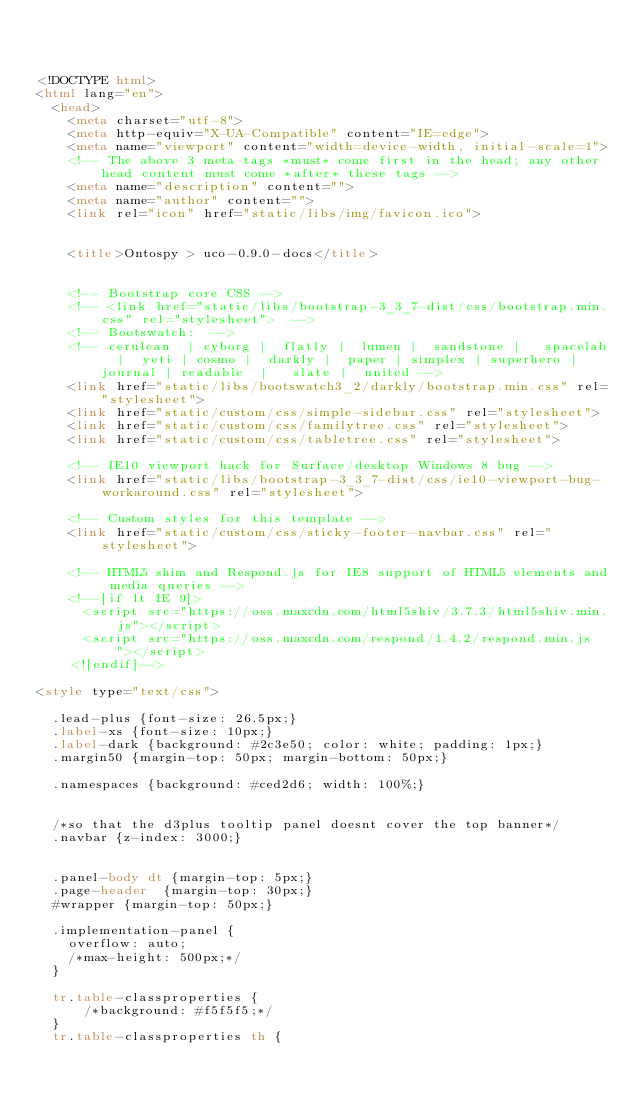<code> <loc_0><loc_0><loc_500><loc_500><_HTML_>


<!DOCTYPE html>
<html lang="en">
  <head>
    <meta charset="utf-8">
    <meta http-equiv="X-UA-Compatible" content="IE=edge">
    <meta name="viewport" content="width=device-width, initial-scale=1">
    <!-- The above 3 meta tags *must* come first in the head; any other head content must come *after* these tags -->
    <meta name="description" content="">
    <meta name="author" content="">
    <link rel="icon" href="static/libs/img/favicon.ico">

	
		<title>Ontospy > uco-0.9.0-docs</title>
	

    <!-- Bootstrap core CSS -->
    <!-- <link href="static/libs/bootstrap-3_3_7-dist/css/bootstrap.min.css" rel="stylesheet">  -->
    <!-- Bootswatch:  -->
    <!-- cerulean  | cyborg |  flatly |  lumen |  sandstone |   spacelab  |  yeti | cosmo |  darkly |  paper | simplex | superhero |  journal | readable  |   slate |  united -->
    <link href="static/libs/bootswatch3_2/darkly/bootstrap.min.css" rel="stylesheet">
    <link href="static/custom/css/simple-sidebar.css" rel="stylesheet">
    <link href="static/custom/css/familytree.css" rel="stylesheet">
    <link href="static/custom/css/tabletree.css" rel="stylesheet">

    <!-- IE10 viewport hack for Surface/desktop Windows 8 bug -->
    <link href="static/libs/bootstrap-3_3_7-dist/css/ie10-viewport-bug-workaround.css" rel="stylesheet">

    <!-- Custom styles for this template -->
    <link href="static/custom/css/sticky-footer-navbar.css" rel="stylesheet">

    <!-- HTML5 shim and Respond.js for IE8 support of HTML5 elements and media queries -->
    <!--[if lt IE 9]>
      <script src="https://oss.maxcdn.com/html5shiv/3.7.3/html5shiv.min.js"></script>
      <script src="https://oss.maxcdn.com/respond/1.4.2/respond.min.js"></script>
    <![endif]-->

<style type="text/css">

  .lead-plus {font-size: 26.5px;}
  .label-xs {font-size: 10px;}
  .label-dark {background: #2c3e50; color: white; padding: 1px;}
  .margin50 {margin-top: 50px; margin-bottom: 50px;}

  .namespaces {background: #ced2d6; width: 100%;}


  /*so that the d3plus tooltip panel doesnt cover the top banner*/
  .navbar {z-index: 3000;}


  .panel-body dt {margin-top: 5px;}
  .page-header  {margin-top: 30px;}
  #wrapper {margin-top: 50px;}

  .implementation-panel {
    overflow: auto;
    /*max-height: 500px;*/
  }

  tr.table-classproperties {
      /*background: #f5f5f5;*/
  }
  tr.table-classproperties th {</code> 